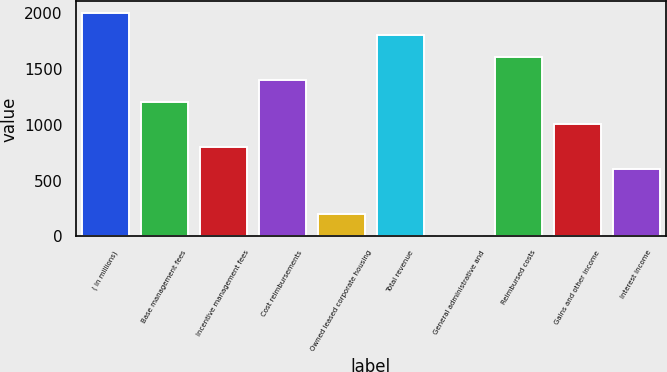<chart> <loc_0><loc_0><loc_500><loc_500><bar_chart><fcel>( in millions)<fcel>Base management fees<fcel>Incentive management fees<fcel>Cost reimbursements<fcel>Owned leased corporate housing<fcel>Total revenue<fcel>General administrative and<fcel>Reimbursed costs<fcel>Gains and other income<fcel>Interest income<nl><fcel>2006<fcel>1204<fcel>803<fcel>1404.5<fcel>201.5<fcel>1805.5<fcel>1<fcel>1605<fcel>1003.5<fcel>602.5<nl></chart> 